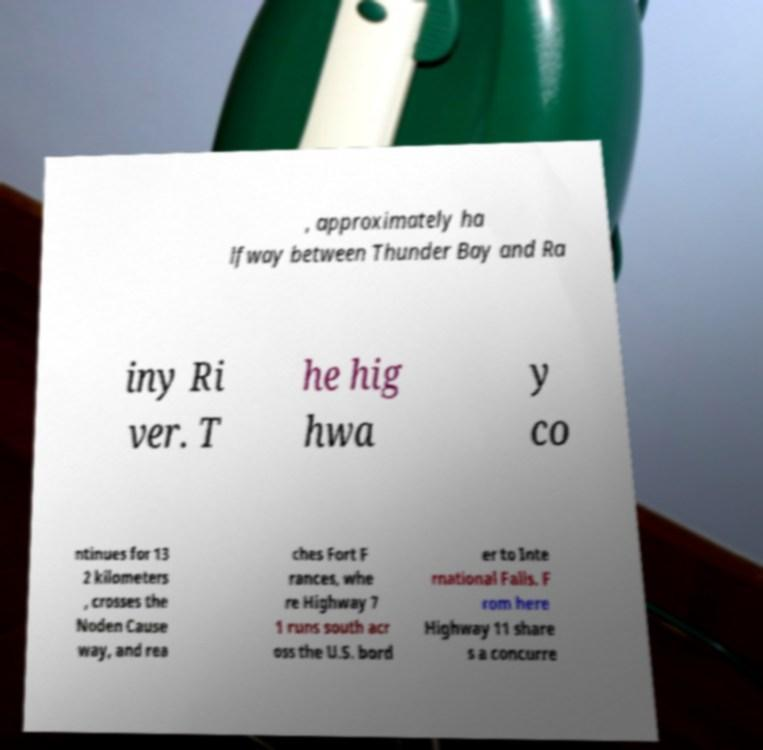For documentation purposes, I need the text within this image transcribed. Could you provide that? , approximately ha lfway between Thunder Bay and Ra iny Ri ver. T he hig hwa y co ntinues for 13 2 kilometers , crosses the Noden Cause way, and rea ches Fort F rances, whe re Highway 7 1 runs south acr oss the U.S. bord er to Inte rnational Falls. F rom here Highway 11 share s a concurre 